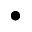Convert formula to latex. <formula><loc_0><loc_0><loc_500><loc_500>\bullet</formula> 